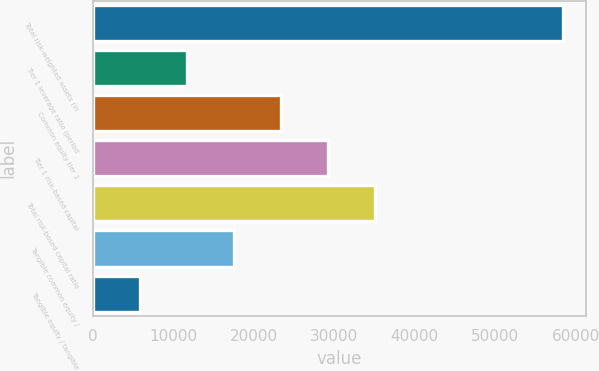<chart> <loc_0><loc_0><loc_500><loc_500><bar_chart><fcel>Total risk-weighted assets (in<fcel>Tier 1 leverage ratio (period<fcel>Common equity tier 1<fcel>Tier 1 risk-based capital<fcel>Total risk-based capital ratio<fcel>Tangible common equity /<fcel>Tangible equity / tangible<nl><fcel>58420<fcel>11690.2<fcel>23372.7<fcel>29213.9<fcel>35055.1<fcel>17531.5<fcel>5849.03<nl></chart> 